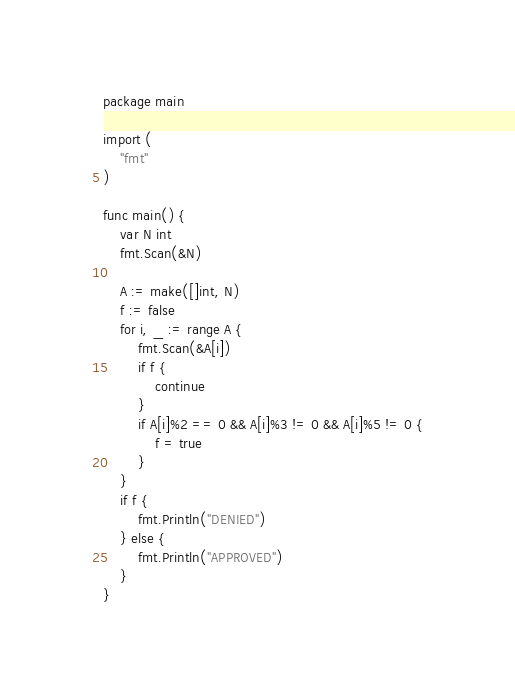<code> <loc_0><loc_0><loc_500><loc_500><_Go_>package main

import (
	"fmt"
)

func main() {
	var N int
	fmt.Scan(&N)

	A := make([]int, N)
	f := false
	for i, _ := range A {
		fmt.Scan(&A[i])
		if f {
			continue
		}
		if A[i]%2 == 0 && A[i]%3 != 0 && A[i]%5 != 0 {
			f = true
		}
	}
	if f {
		fmt.Println("DENIED")
	} else {
		fmt.Println("APPROVED")
	}
}
</code> 